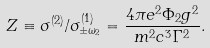<formula> <loc_0><loc_0><loc_500><loc_500>Z \equiv \sigma ^ { ( 2 ) } / \sigma _ { \pm \omega _ { 2 } } ^ { ( 1 ) } = \frac { 4 \pi e ^ { 2 } \Phi _ { 2 } g ^ { 2 } } { m ^ { 2 } c ^ { 3 } \Gamma ^ { 2 } } .</formula> 